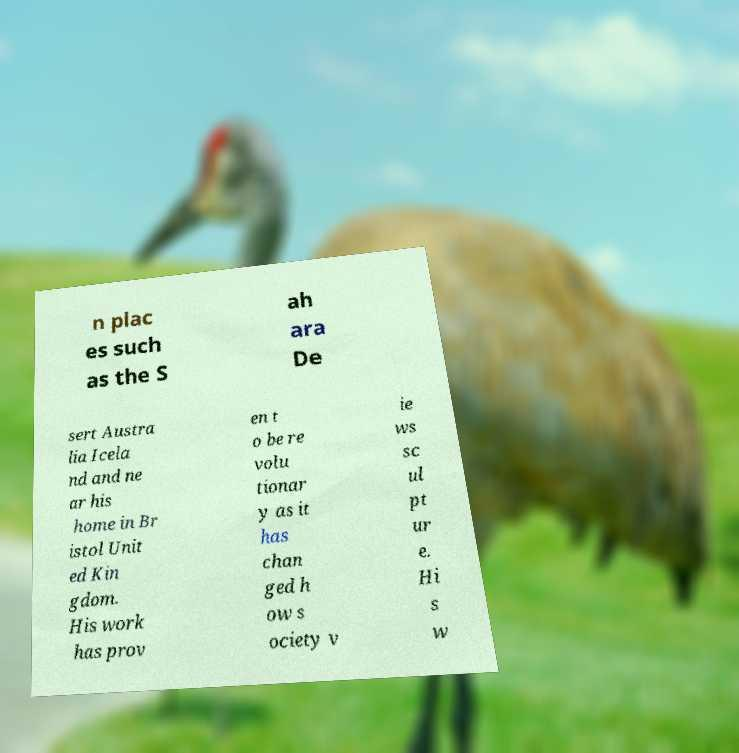Can you accurately transcribe the text from the provided image for me? n plac es such as the S ah ara De sert Austra lia Icela nd and ne ar his home in Br istol Unit ed Kin gdom. His work has prov en t o be re volu tionar y as it has chan ged h ow s ociety v ie ws sc ul pt ur e. Hi s w 